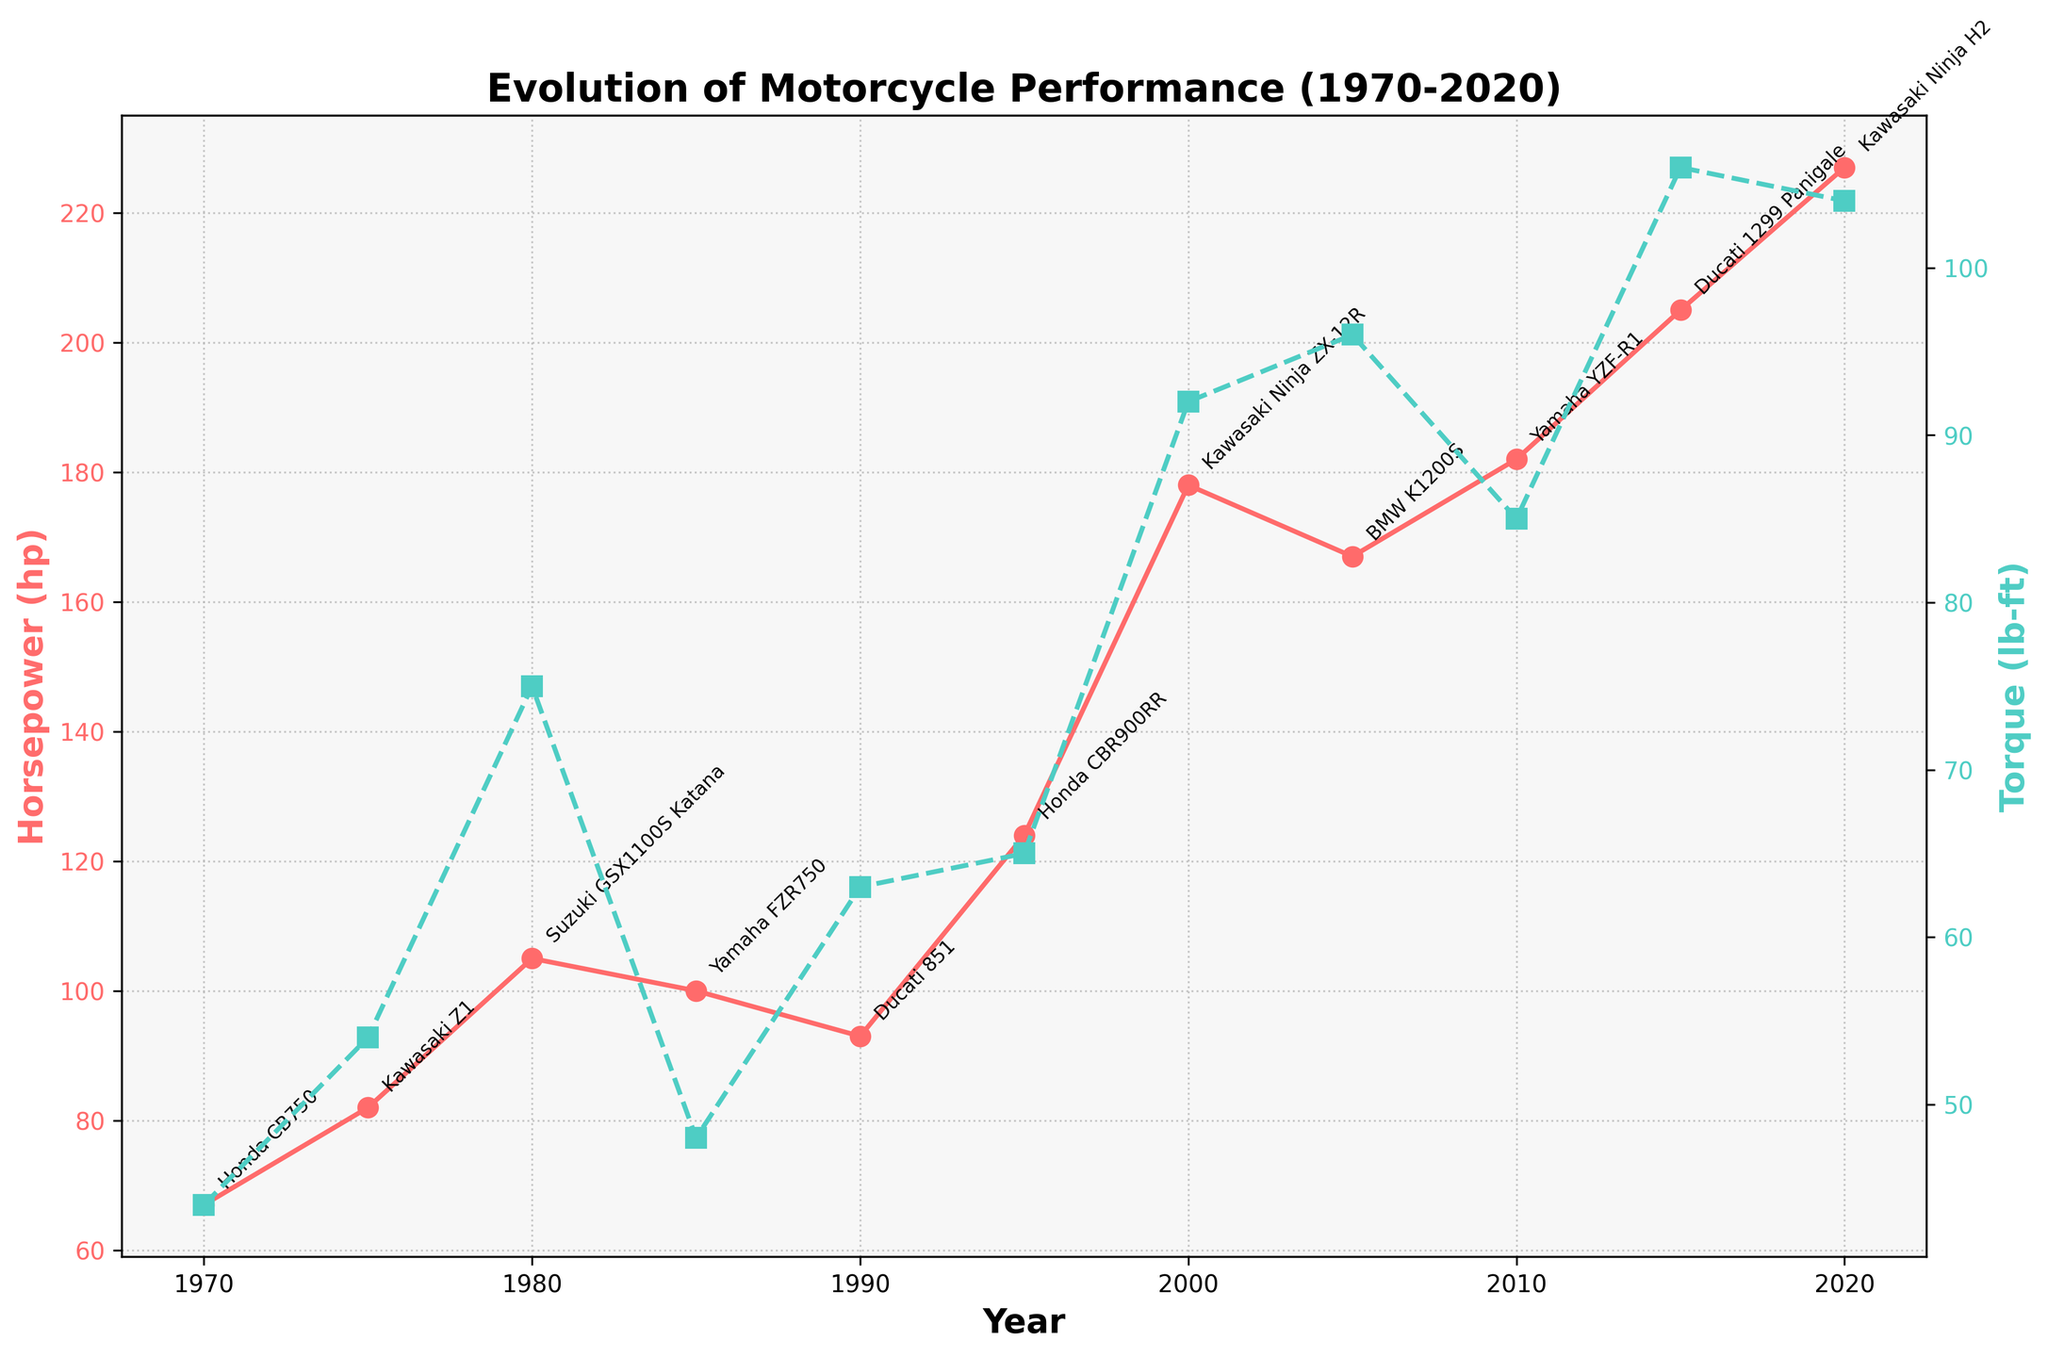What's the title of the plot? The title of the plot is displayed at the top of the chart, describing the main subject of the visual representation.
Answer: Evolution of Motorcycle Performance (1970-2020) Which color represents Horsepower? The color used for Horsepower is indicated in the label on the left axis and corresponds to the plotted line with circular markers.
Answer: Red How many motorcycle models are shown between 1970 and 2020? Each year on the x-axis with a data point represents a motorcycle model. We need to count these points.
Answer: 11 What is the highest Torque value shown, and in which year? The highest Torque value can be identified from the peaks of the green plot line, and the corresponding year is indicated on the x-axis.
Answer: 106 lb-ft in 2015 Which motorcycle model had the lowest Horsepower in the dataset, and in which year was it released? The lowest Horsepower value is the minimal point on the red plot line, noted in both the value and the year.
Answer: Honda CB750 in 1970 How many years saw an increase in Horsepower from the previous data point? To determine this, compare each year's Horsepower value to the previous one to count the years with an increase.
Answer: 8 By how much did Horsepower increase from 1980 to 2000? Subtract the 1980 Horsepower value from the 2000 value.
Answer: 73 hp Which motorcycle released had the highest Horsepower in 2015? The annotation near the peak value for Horsepower in 2015 provides the name of the specific motorcycle model.
Answer: Ducati 1299 Panigale Did Torque and Horsepower both peak in the same year? Compare the peak points of both the Torque (green) and Horsepower (red) lines to see if they align to the same year on the x-axis.
Answer: No Is there any year where Torque values were equal or greater than Horsepower values? Examine the plot lines to see if the green line for Torque crosses or matches the red line for Horsepower in any year.
Answer: No 